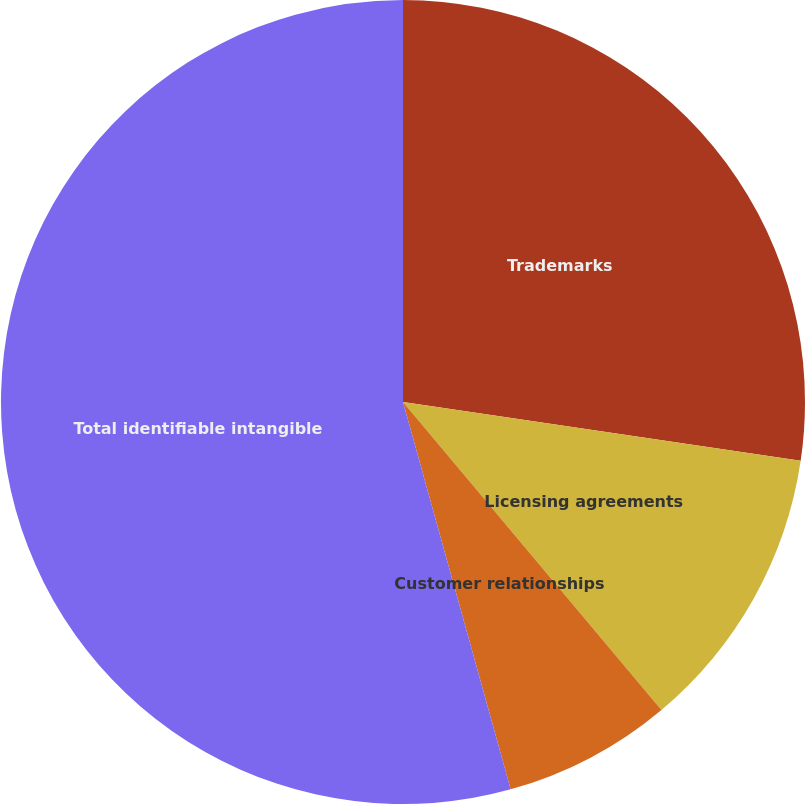Convert chart to OTSL. <chart><loc_0><loc_0><loc_500><loc_500><pie_chart><fcel>Trademarks<fcel>Licensing agreements<fcel>Customer relationships<fcel>Total identifiable intangible<nl><fcel>27.34%<fcel>11.55%<fcel>6.8%<fcel>54.32%<nl></chart> 